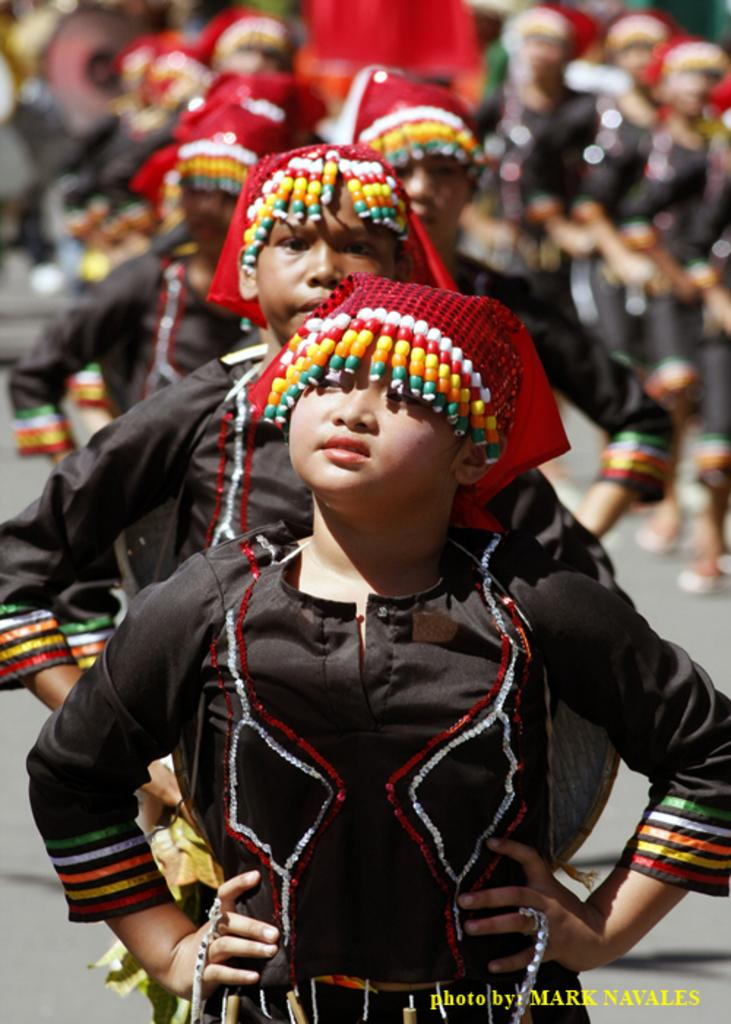What is the main feature of the picture? There is a road in the picture. What are the children doing on the road? There are many children standing on the road. What can be observed about the children's attire? The children are wearing different costumes. How many cherries are on the stem in the image? There are no cherries or stems present in the image. What type of account is being discussed in the image? There is no discussion of an account in the image. 